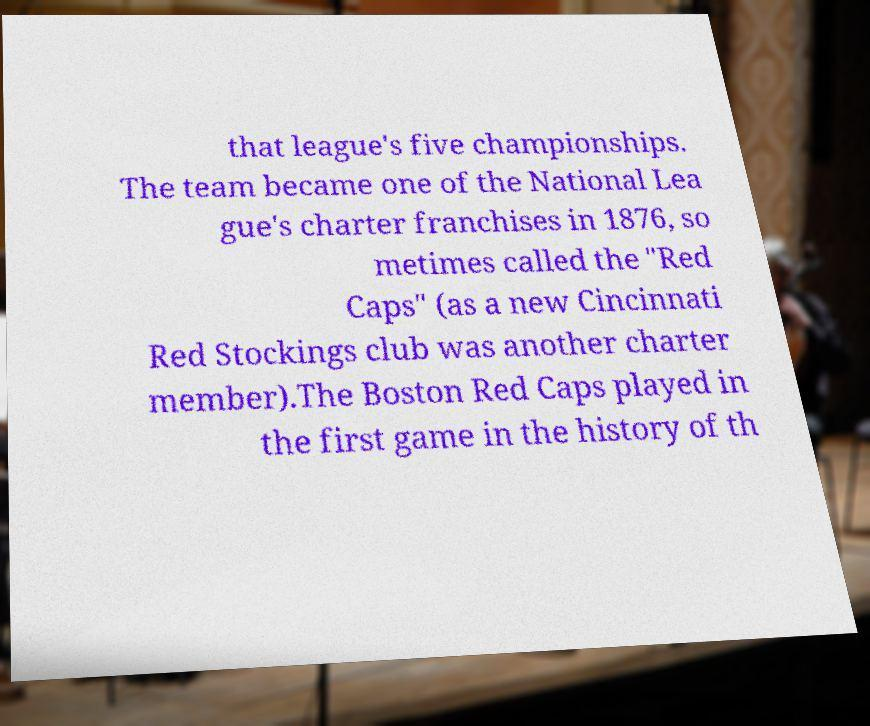Please identify and transcribe the text found in this image. that league's five championships. The team became one of the National Lea gue's charter franchises in 1876, so metimes called the "Red Caps" (as a new Cincinnati Red Stockings club was another charter member).The Boston Red Caps played in the first game in the history of th 